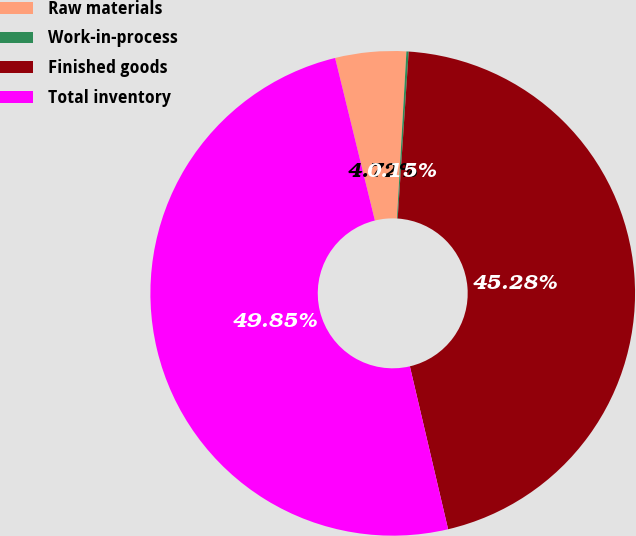Convert chart. <chart><loc_0><loc_0><loc_500><loc_500><pie_chart><fcel>Raw materials<fcel>Work-in-process<fcel>Finished goods<fcel>Total inventory<nl><fcel>4.72%<fcel>0.15%<fcel>45.28%<fcel>49.85%<nl></chart> 